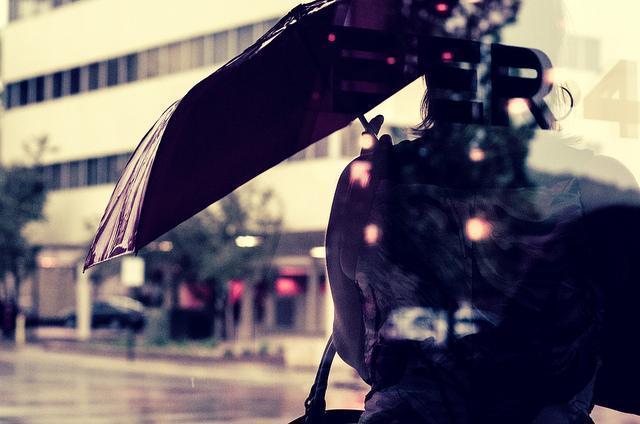How many cars can be seen?
Give a very brief answer. 1. 